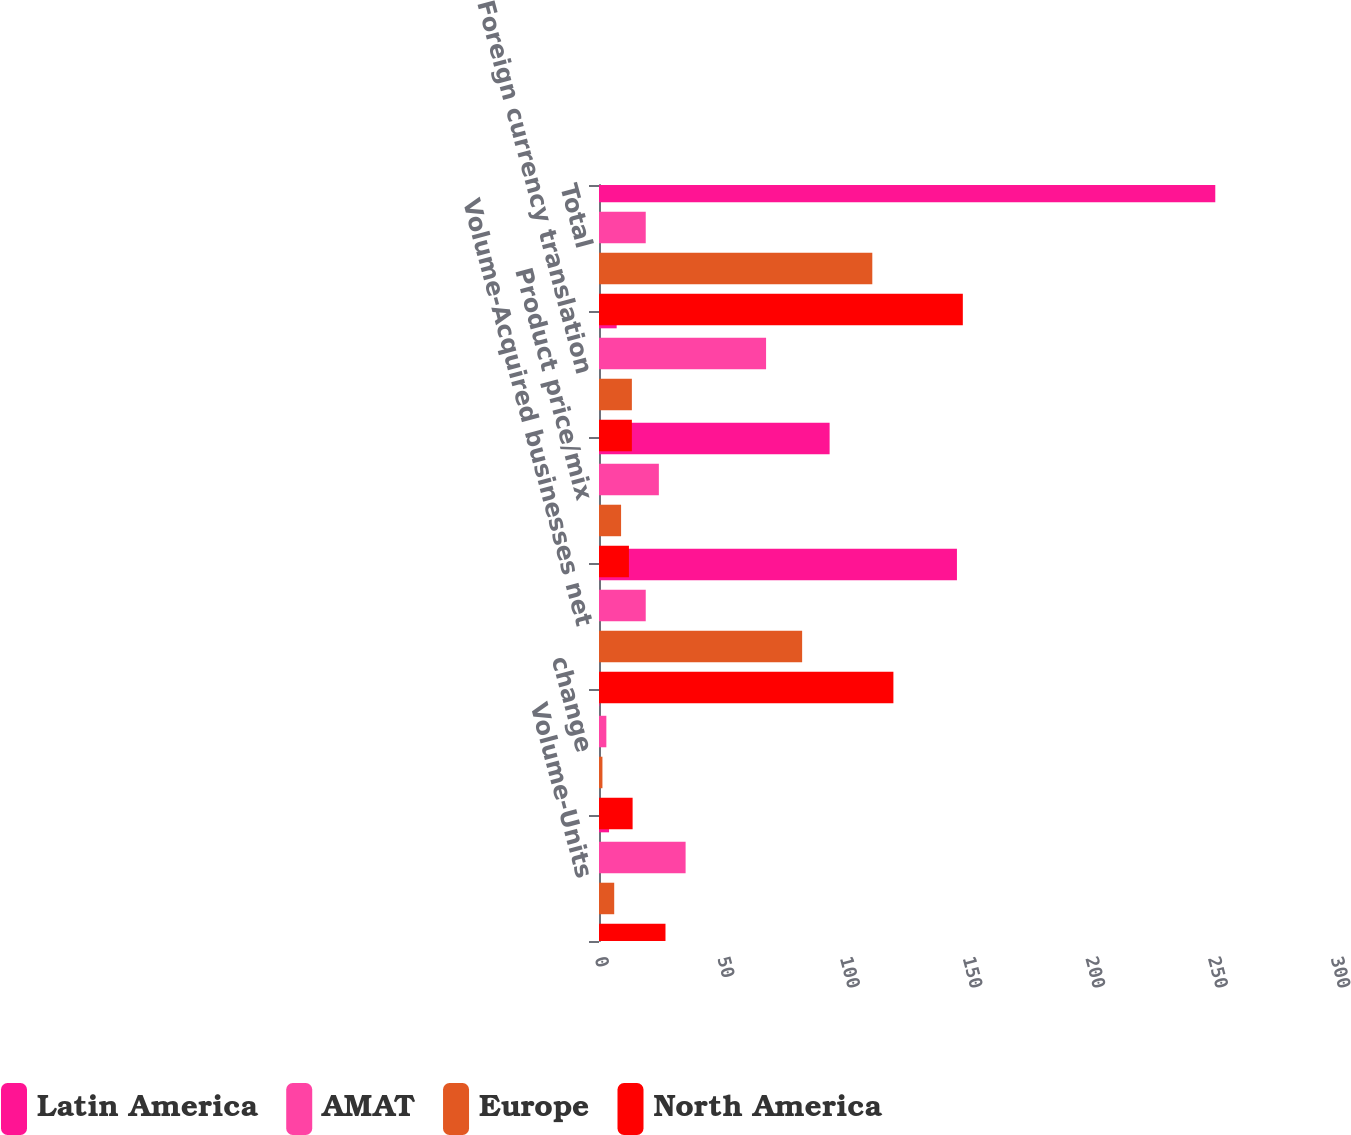Convert chart. <chart><loc_0><loc_0><loc_500><loc_500><stacked_bar_chart><ecel><fcel>Volume-Units<fcel>change<fcel>Volume-Acquired businesses net<fcel>Product price/mix<fcel>Foreign currency translation<fcel>Total<nl><fcel>Latin America<fcel>4.1<fcel>0.2<fcel>145.9<fcel>94<fcel>7.2<fcel>251.2<nl><fcel>AMAT<fcel>35.3<fcel>3<fcel>19.05<fcel>24.4<fcel>68.1<fcel>19.05<nl><fcel>Europe<fcel>6.2<fcel>1.4<fcel>82.8<fcel>9<fcel>13.4<fcel>111.4<nl><fcel>North America<fcel>27.1<fcel>13.7<fcel>120<fcel>12.2<fcel>13.4<fcel>148.3<nl></chart> 